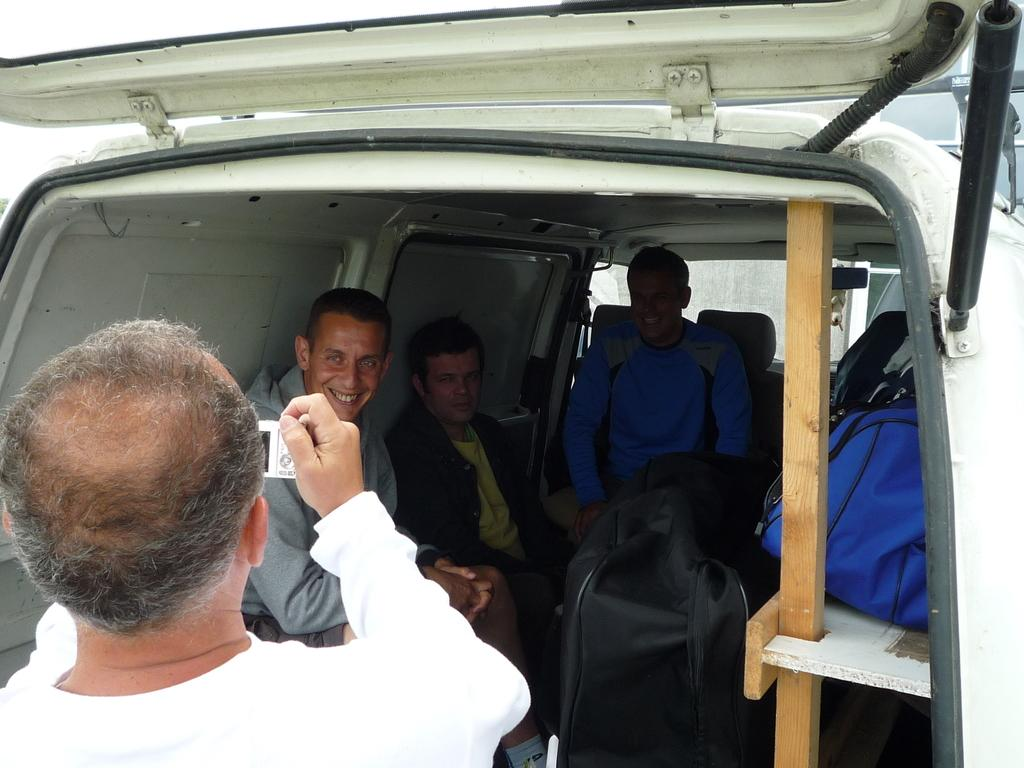How many people are inside the car in the image? There are three persons sitting inside the car. What is happening on the left side of the image? There is a person standing on the left side, capturing an image with a camera. What is the person standing doing? The person standing is capturing an image with a camera. What type of magic is the person standing performing in the image? There is no magic being performed in the image; the person standing is capturing an image with a camera. How many bulbs are visible in the image? There is no mention of bulbs in the image; it features a car with people inside and a person standing with a camera. 